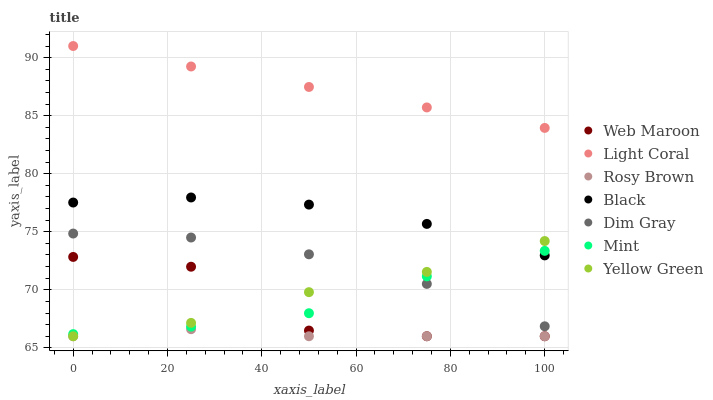Does Rosy Brown have the minimum area under the curve?
Answer yes or no. Yes. Does Light Coral have the maximum area under the curve?
Answer yes or no. Yes. Does Yellow Green have the minimum area under the curve?
Answer yes or no. No. Does Yellow Green have the maximum area under the curve?
Answer yes or no. No. Is Light Coral the smoothest?
Answer yes or no. Yes. Is Web Maroon the roughest?
Answer yes or no. Yes. Is Yellow Green the smoothest?
Answer yes or no. No. Is Yellow Green the roughest?
Answer yes or no. No. Does Yellow Green have the lowest value?
Answer yes or no. Yes. Does Light Coral have the lowest value?
Answer yes or no. No. Does Light Coral have the highest value?
Answer yes or no. Yes. Does Yellow Green have the highest value?
Answer yes or no. No. Is Rosy Brown less than Light Coral?
Answer yes or no. Yes. Is Light Coral greater than Mint?
Answer yes or no. Yes. Does Rosy Brown intersect Yellow Green?
Answer yes or no. Yes. Is Rosy Brown less than Yellow Green?
Answer yes or no. No. Is Rosy Brown greater than Yellow Green?
Answer yes or no. No. Does Rosy Brown intersect Light Coral?
Answer yes or no. No. 